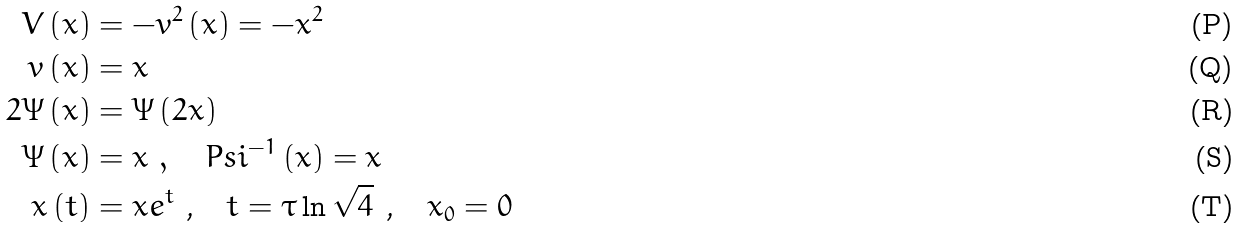<formula> <loc_0><loc_0><loc_500><loc_500>V \left ( x \right ) & = - v ^ { 2 } \left ( x \right ) = - x ^ { 2 } \\ v \left ( x \right ) & = x \\ 2 \Psi \left ( x \right ) & = \Psi \left ( 2 x \right ) \\ \Psi \left ( x \right ) & = x \ , \quad P s i ^ { - 1 } \left ( x \right ) = x \\ x \left ( t \right ) & = x e ^ { t } \text {\ ,\quad } t = \tau \ln \sqrt { 4 } \text { , \ \ } x _ { 0 } = 0</formula> 